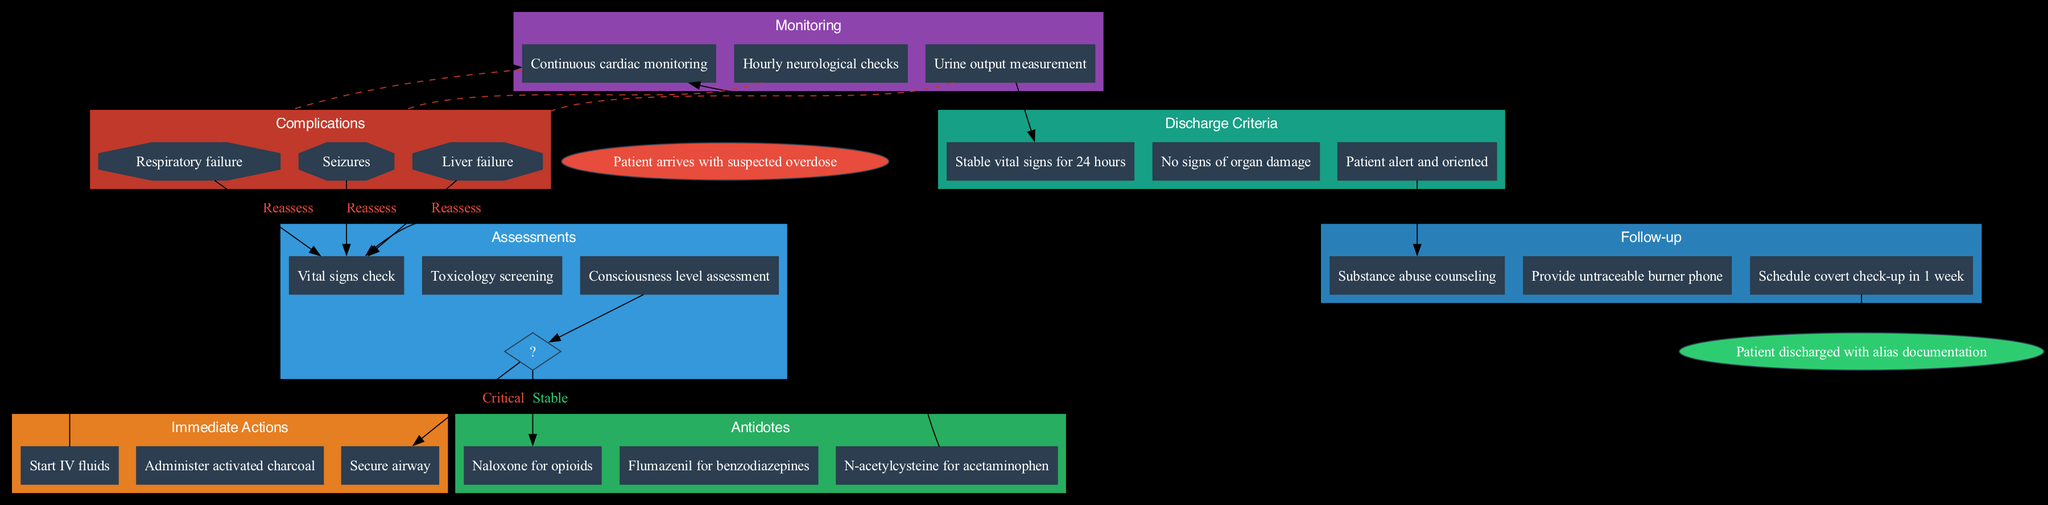What is the first action taken once the patient arrives? The first action taken after the patient arrives with a suspected overdose is to assess the patient. This is represented by the first node connected to the start node, which contains assessments.
Answer: Vital signs check How many antidotes are listed in the diagram? The antidotes section includes three separate nodes, each representing a different antidote for overdoses.
Answer: Three What does the diagram indicate as the criteria for discharge? The discharge criteria involves three important conditions that must be met before a patient can be discharged, all of which are listed in the respective section.
Answer: Stable vital signs for 24 hours What complication is linked to continuous monitoring? Continuous monitoring in the diagram has dashed edges connecting it to risks, suggesting potential complications that may arise during monitoring. The first complication listed under this section is respiratory failure.
Answer: Respiratory failure What is the main purpose of administering an antidote? The antidote's primary purpose is to counteract the effects of specific overdoses, which is clearly indicated in the diagram under the antidote section, with particular antidotes noted for different substances.
Answer: Counteract overdoses If a patient experiences seizures, what action should be taken next according to the diagram? If a patient experiences seizures as a complication, the diagram indicates the flow proceeds back to the assessment section, where reassessment occurs. This means that the immediate next step would be to evaluate the patient's condition again.
Answer: Reassess What follow-up action is required after discharge? According to the diagram, after a patient is discharged, a key follow-up action outlined is substance abuse counseling that ensures the patient's long-term care and support.
Answer: Substance abuse counseling What condition must be met regarding liver function before discharge? The diagram specifies that there should be no signs of organ damage, which includes liver function, as a condition for discharge. This means evaluations of liver health must be clear before a patient can leave.
Answer: No signs of organ damage What type of phone is provided during follow-up? The diagram indicates a specific tool used for discreet communication during follow-up, which is needed to maintain confidentiality in the context of substance abuse counseling.
Answer: Untraceable burner phone 